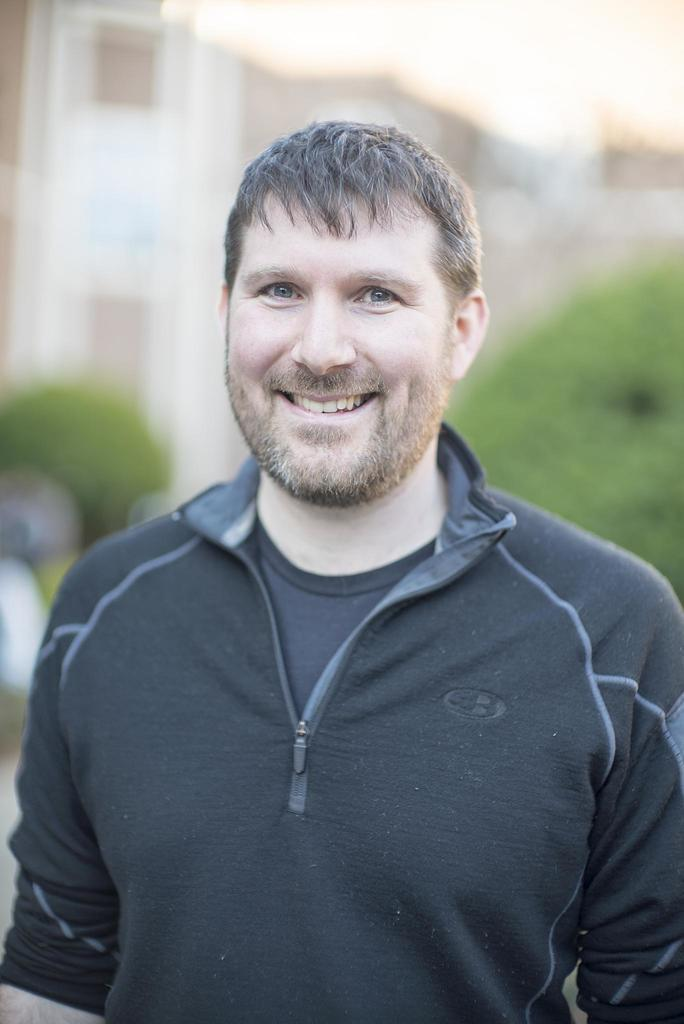Who is present in the image? There is a man in the image. What is the man doing in the image? The man is smiling in the image. What is the man wearing in the image? The man is wearing a black color sweater in the image. What type of harmony is being played by the quince in the image? There is no quince or harmony present in the image; it features a man who is smiling and wearing a black color sweater. 